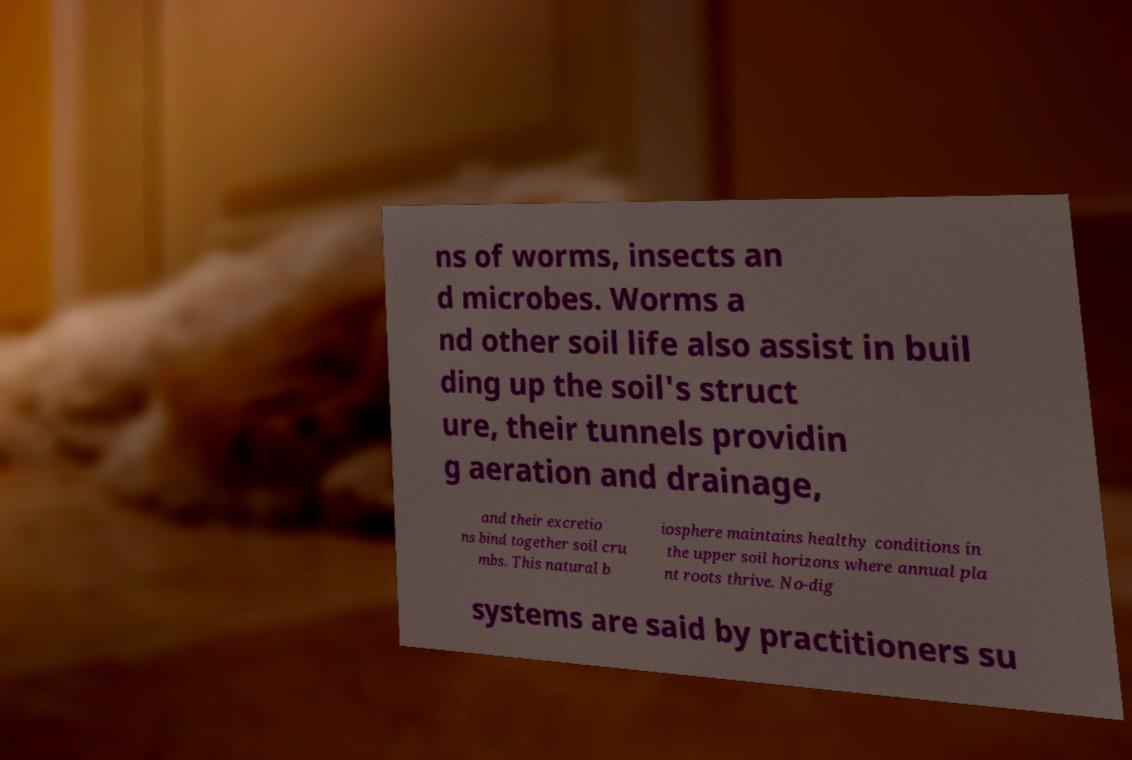Could you extract and type out the text from this image? ns of worms, insects an d microbes. Worms a nd other soil life also assist in buil ding up the soil's struct ure, their tunnels providin g aeration and drainage, and their excretio ns bind together soil cru mbs. This natural b iosphere maintains healthy conditions in the upper soil horizons where annual pla nt roots thrive. No-dig systems are said by practitioners su 